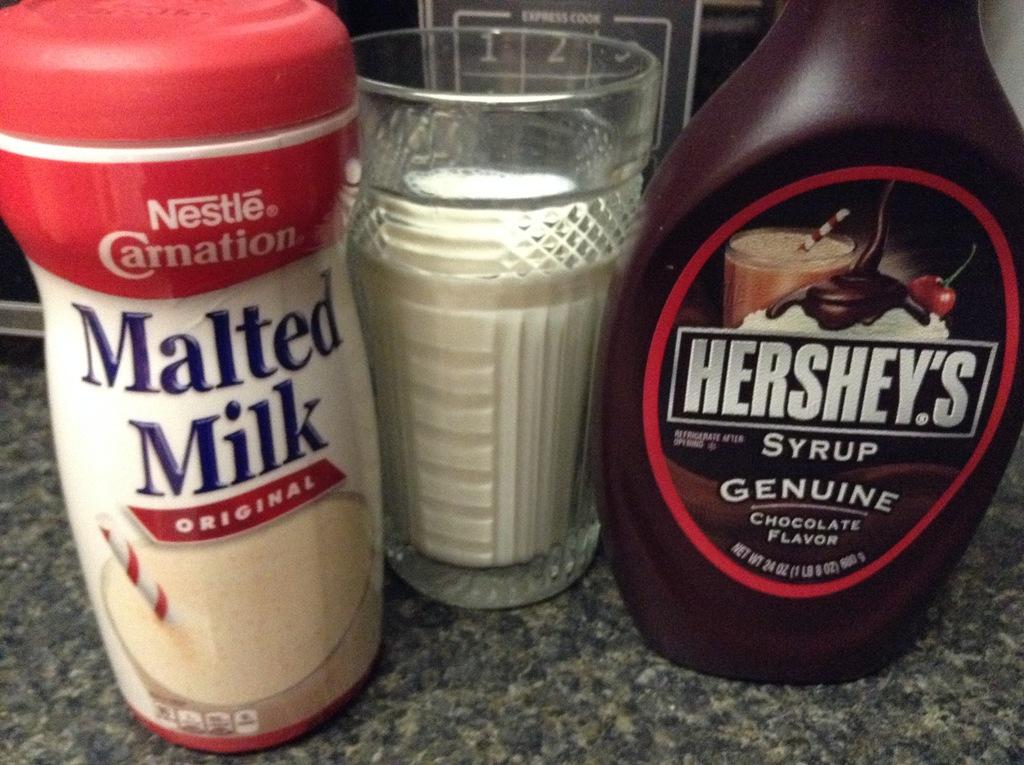How many bottles can be seen in the image? There are two bottles in the image. What type of beverage is in the glass in the image? There is a glass of milk in the image. What appliance is visible in the image? There is a microwave visible in the image. Where is the microwave located in the image? The microwave is on a kitchen platform. How many clocks are present in the image? There are no clocks visible in the image. What color is the zebra in the image? There is no zebra present in the image. 